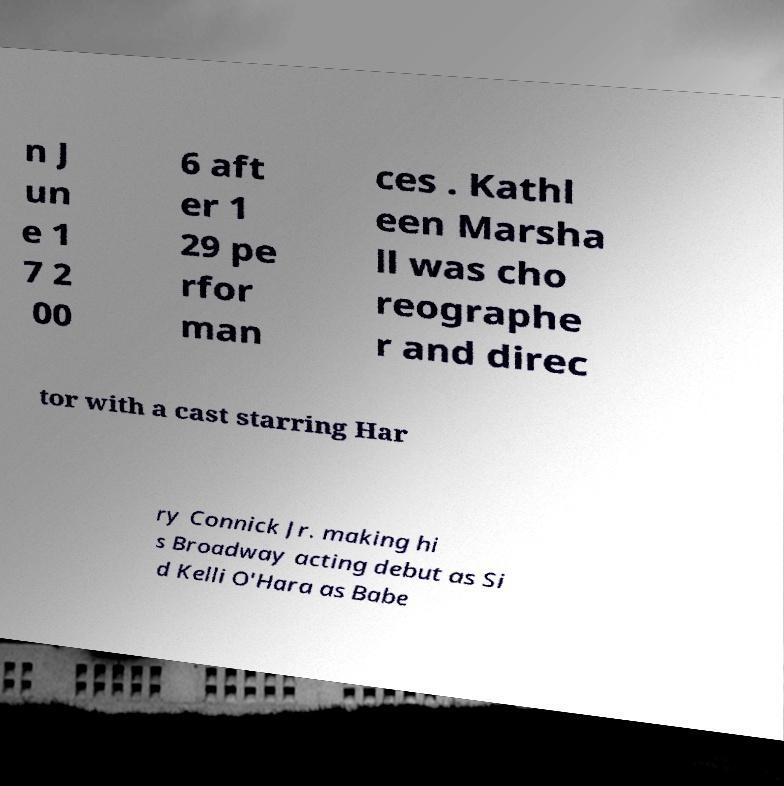What messages or text are displayed in this image? I need them in a readable, typed format. n J un e 1 7 2 00 6 aft er 1 29 pe rfor man ces . Kathl een Marsha ll was cho reographe r and direc tor with a cast starring Har ry Connick Jr. making hi s Broadway acting debut as Si d Kelli O'Hara as Babe 